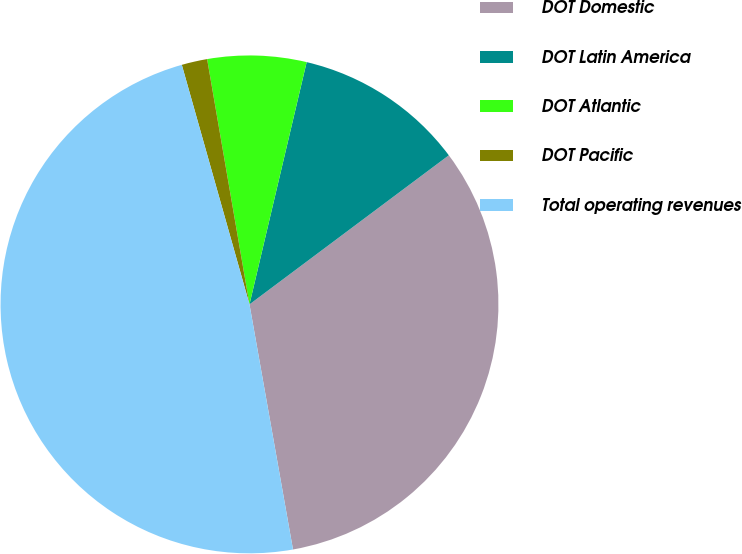Convert chart to OTSL. <chart><loc_0><loc_0><loc_500><loc_500><pie_chart><fcel>DOT Domestic<fcel>DOT Latin America<fcel>DOT Atlantic<fcel>DOT Pacific<fcel>Total operating revenues<nl><fcel>32.42%<fcel>11.09%<fcel>6.41%<fcel>1.66%<fcel>48.41%<nl></chart> 